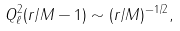Convert formula to latex. <formula><loc_0><loc_0><loc_500><loc_500>Q ^ { 2 } _ { \ell } ( r / M - 1 ) \sim ( r / M ) ^ { - 1 / 2 } ,</formula> 